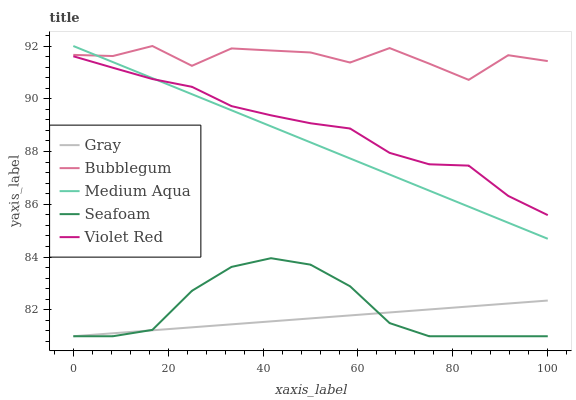Does Violet Red have the minimum area under the curve?
Answer yes or no. No. Does Violet Red have the maximum area under the curve?
Answer yes or no. No. Is Violet Red the smoothest?
Answer yes or no. No. Is Violet Red the roughest?
Answer yes or no. No. Does Violet Red have the lowest value?
Answer yes or no. No. Does Violet Red have the highest value?
Answer yes or no. No. Is Seafoam less than Medium Aqua?
Answer yes or no. Yes. Is Violet Red greater than Seafoam?
Answer yes or no. Yes. Does Seafoam intersect Medium Aqua?
Answer yes or no. No. 